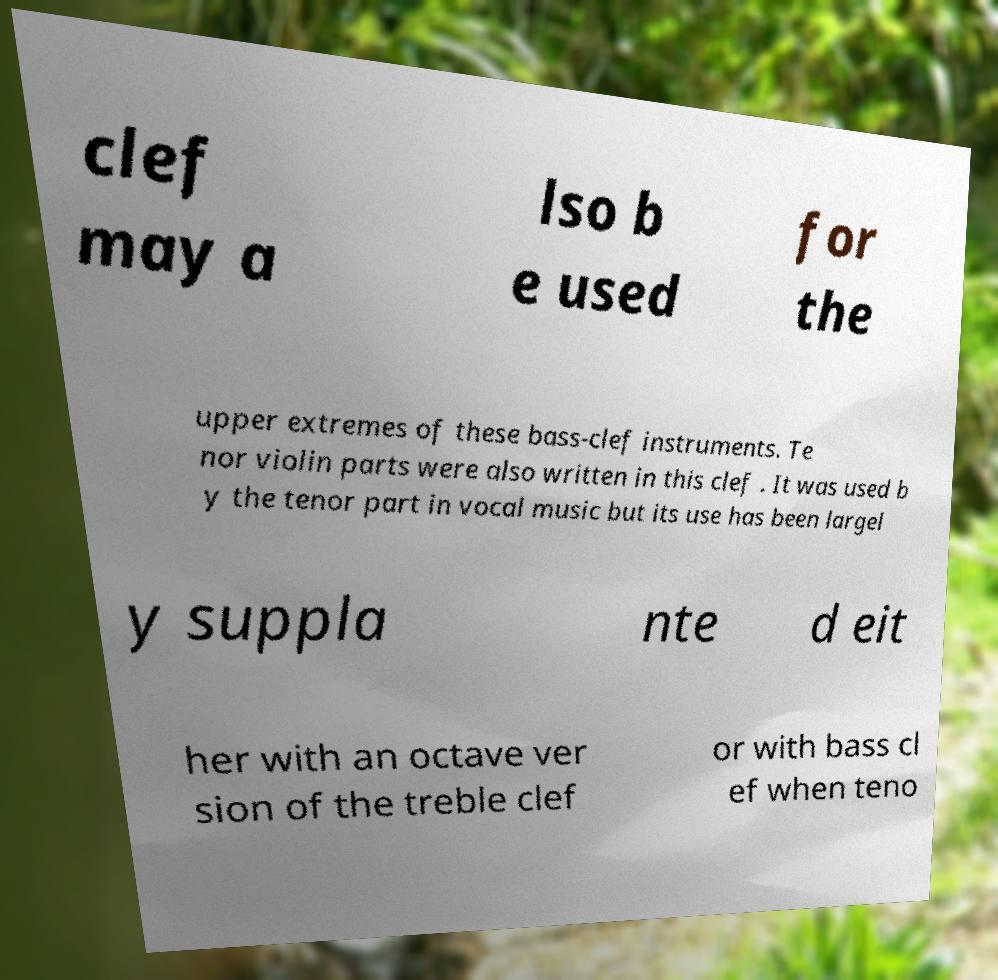Could you extract and type out the text from this image? clef may a lso b e used for the upper extremes of these bass-clef instruments. Te nor violin parts were also written in this clef . It was used b y the tenor part in vocal music but its use has been largel y suppla nte d eit her with an octave ver sion of the treble clef or with bass cl ef when teno 